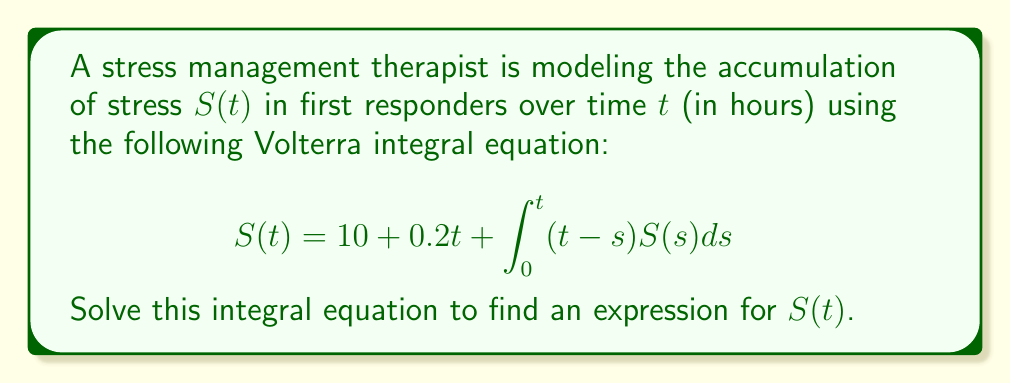Show me your answer to this math problem. To solve this Volterra integral equation, we'll use the following steps:

1) First, we differentiate both sides of the equation with respect to $t$:

   $$\frac{d}{dt}S(t) = 0.2 + \frac{d}{dt}\int_0^t (t-s)S(s)ds$$

2) Using Leibniz's rule for differentiating an integral:

   $$S'(t) = 0.2 + \int_0^t S(s)ds + 0$$

3) Differentiating again:

   $$S''(t) = S(t)$$

4) This is a second-order linear differential equation. The general solution is:

   $$S(t) = Ae^t + Be^{-t}$$

5) To find $A$ and $B$, we use the initial conditions from the original equation:

   At $t=0$: $S(0) = 10$, so $A + B = 10$

6) Substituting the general solution into the original equation:

   $$Ae^t + Be^{-t} = 10 + 0.2t + \int_0^t (t-s)(Ae^s + Be^{-s})ds$$

7) Solving the integral:

   $$Ae^t + Be^{-t} = 10 + 0.2t + A(e^t - 1 - t) + B(1 - e^{-t} - t)$$

8) Comparing coefficients:

   $e^t$ terms: $A = A$
   $e^{-t}$ terms: $B = -B$, so $B = 0$
   Constant terms: $10 = 10 - A + B$, so $A = 10$

9) Therefore, the solution is:

   $$S(t) = 10e^t$$
Answer: $S(t) = 10e^t$ 